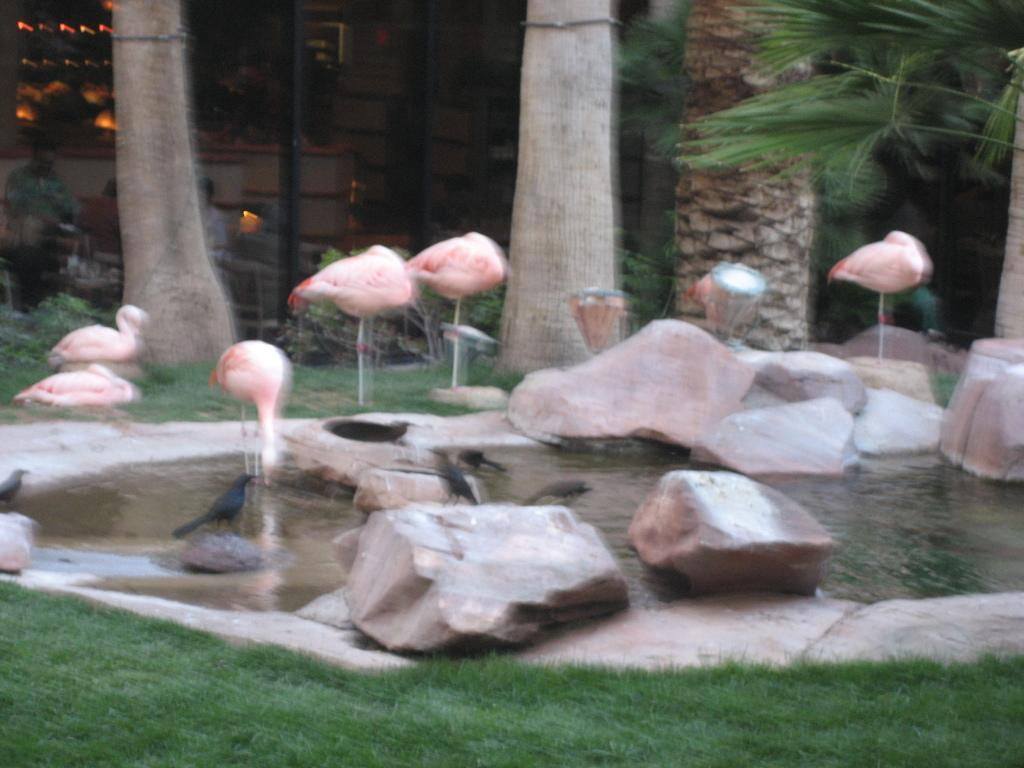What is the main feature of the water surface in the image? There is a small water surface in the image. What type of birds can be seen in the image? There are birds in the image. What other animals are present in the image? There are cranes in the image. What type of vegetation can be seen in the image? There are tall trees and grass in the image. What type of lettuce is being used as a hat by the crane in the image? There is no lettuce present in the image, nor is any crane wearing a hat. 